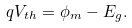<formula> <loc_0><loc_0><loc_500><loc_500>q V _ { t h } = \phi _ { m } - E _ { g } .</formula> 